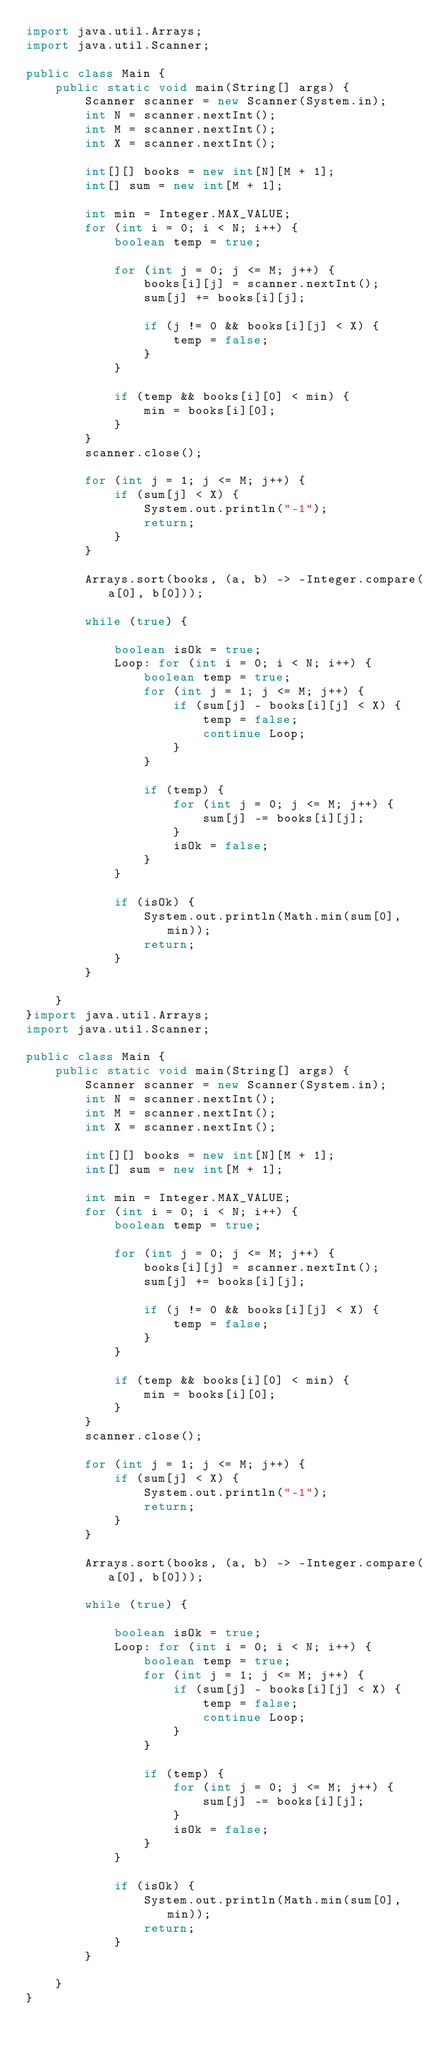<code> <loc_0><loc_0><loc_500><loc_500><_Java_>import java.util.Arrays;
import java.util.Scanner;

public class Main {
    public static void main(String[] args) {
        Scanner scanner = new Scanner(System.in);
        int N = scanner.nextInt();
        int M = scanner.nextInt();
        int X = scanner.nextInt();

        int[][] books = new int[N][M + 1];
        int[] sum = new int[M + 1];

        int min = Integer.MAX_VALUE;
        for (int i = 0; i < N; i++) {
            boolean temp = true;

            for (int j = 0; j <= M; j++) {
                books[i][j] = scanner.nextInt();
                sum[j] += books[i][j];

                if (j != 0 && books[i][j] < X) {
                    temp = false;
                }
            }

            if (temp && books[i][0] < min) {
                min = books[i][0];
            }
        }
        scanner.close();

        for (int j = 1; j <= M; j++) {
            if (sum[j] < X) {
                System.out.println("-1");
                return;
            }
        }

        Arrays.sort(books, (a, b) -> -Integer.compare(a[0], b[0]));

        while (true) {

            boolean isOk = true;
            Loop: for (int i = 0; i < N; i++) {
                boolean temp = true;
                for (int j = 1; j <= M; j++) {
                    if (sum[j] - books[i][j] < X) {
                        temp = false;
                        continue Loop;
                    }
                }

                if (temp) {
                    for (int j = 0; j <= M; j++) {
                        sum[j] -= books[i][j];
                    }
                    isOk = false;
                }
            }

            if (isOk) {
                System.out.println(Math.min(sum[0], min));
                return;
            }
        }

    }
}import java.util.Arrays;
import java.util.Scanner;

public class Main {
    public static void main(String[] args) {
        Scanner scanner = new Scanner(System.in);
        int N = scanner.nextInt();
        int M = scanner.nextInt();
        int X = scanner.nextInt();

        int[][] books = new int[N][M + 1];
        int[] sum = new int[M + 1];

        int min = Integer.MAX_VALUE;
        for (int i = 0; i < N; i++) {
            boolean temp = true;

            for (int j = 0; j <= M; j++) {
                books[i][j] = scanner.nextInt();
                sum[j] += books[i][j];

                if (j != 0 && books[i][j] < X) {
                    temp = false;
                }
            }

            if (temp && books[i][0] < min) {
                min = books[i][0];
            }
        }
        scanner.close();

        for (int j = 1; j <= M; j++) {
            if (sum[j] < X) {
                System.out.println("-1");
                return;
            }
        }

        Arrays.sort(books, (a, b) -> -Integer.compare(a[0], b[0]));

        while (true) {

            boolean isOk = true;
            Loop: for (int i = 0; i < N; i++) {
                boolean temp = true;
                for (int j = 1; j <= M; j++) {
                    if (sum[j] - books[i][j] < X) {
                        temp = false;
                        continue Loop;
                    }
                }

                if (temp) {
                    for (int j = 0; j <= M; j++) {
                        sum[j] -= books[i][j];
                    }
                    isOk = false;
                }
            }

            if (isOk) {
                System.out.println(Math.min(sum[0], min));
                return;
            }
        }

    }
}</code> 